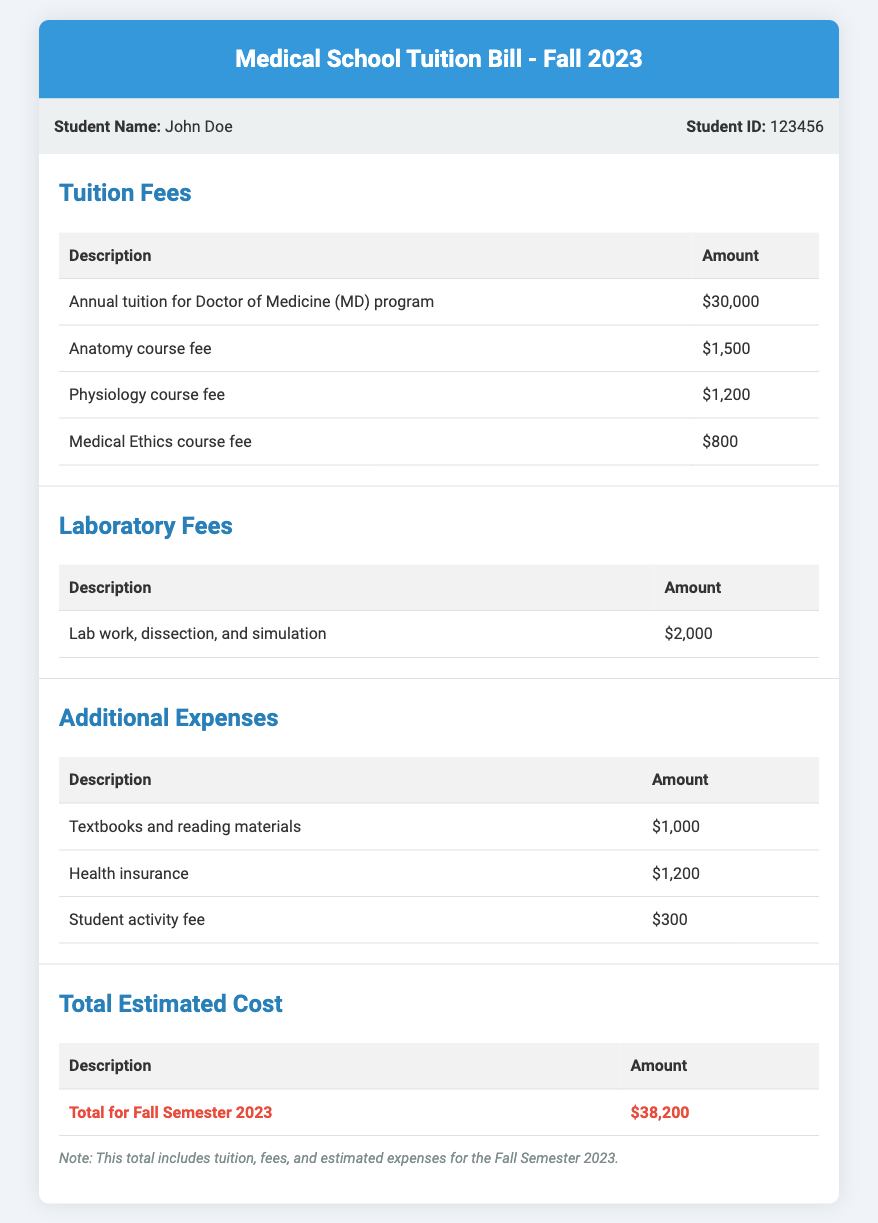What is the total estimated cost for the Fall Semester 2023? The total estimated cost is presented at the end of the document, which combines tuition, fees, and other expenses.
Answer: $38,200 What are the additional expenses listed in the bill? The additional expenses section outlines specific costs that are not part of tuition or laboratory fees, including textbooks, health insurance, and activity fees.
Answer: Textbooks and reading materials, Health insurance, Student activity fee How much is the Anatomy course fee? The fee specifically for the Anatomy course is given in the tuition fees section of the bill.
Answer: $1,500 What is the monthly cost of health insurance? The health insurance fee is provided as a part of additional expenses in the document.
Answer: $1,200 How much is the laboratory fee for lab work and simulation? The document contains a line item specifically detailing the laboratory fee for lab work, dissection, and simulation.
Answer: $2,000 What is included in the total estimated cost? The total estimated cost combines various fees associated with tuition, laboratory work, and additional expenses for the semester.
Answer: Tuition, fees, and estimated expenses How many course fees are listed in the tuition fees section? The tuition fees section includes distinct fees for multiple courses, which can be counted from the entries in that section.
Answer: 3 What is the student name mentioned in the document? The document has been created for a specific student, whose name is clearly stated at the top.
Answer: John Doe What is the description of the total cost provided in the document? The total cost section describes what is being summed to create the final total for the semester.
Answer: Total for Fall Semester 2023 